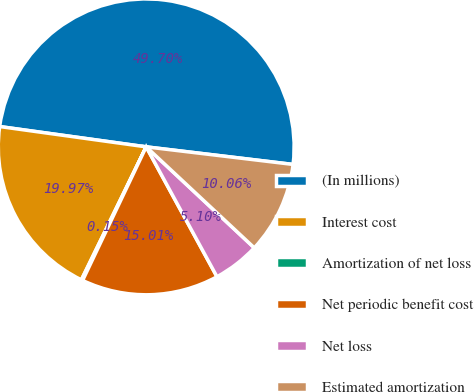<chart> <loc_0><loc_0><loc_500><loc_500><pie_chart><fcel>(In millions)<fcel>Interest cost<fcel>Amortization of net loss<fcel>Net periodic benefit cost<fcel>Net loss<fcel>Estimated amortization<nl><fcel>49.7%<fcel>19.97%<fcel>0.15%<fcel>15.01%<fcel>5.1%<fcel>10.06%<nl></chart> 